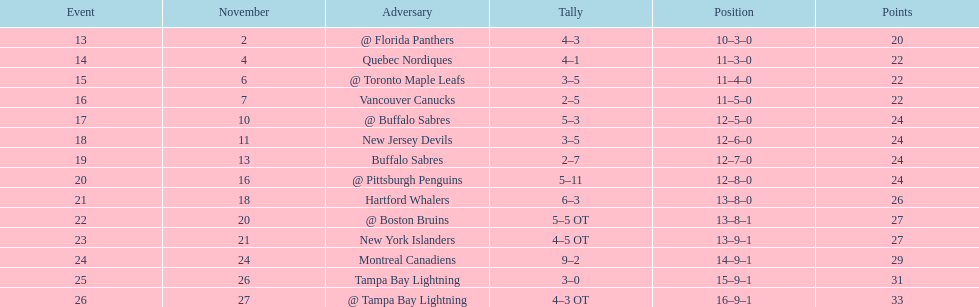What was the number of wins the philadelphia flyers had? 35. 